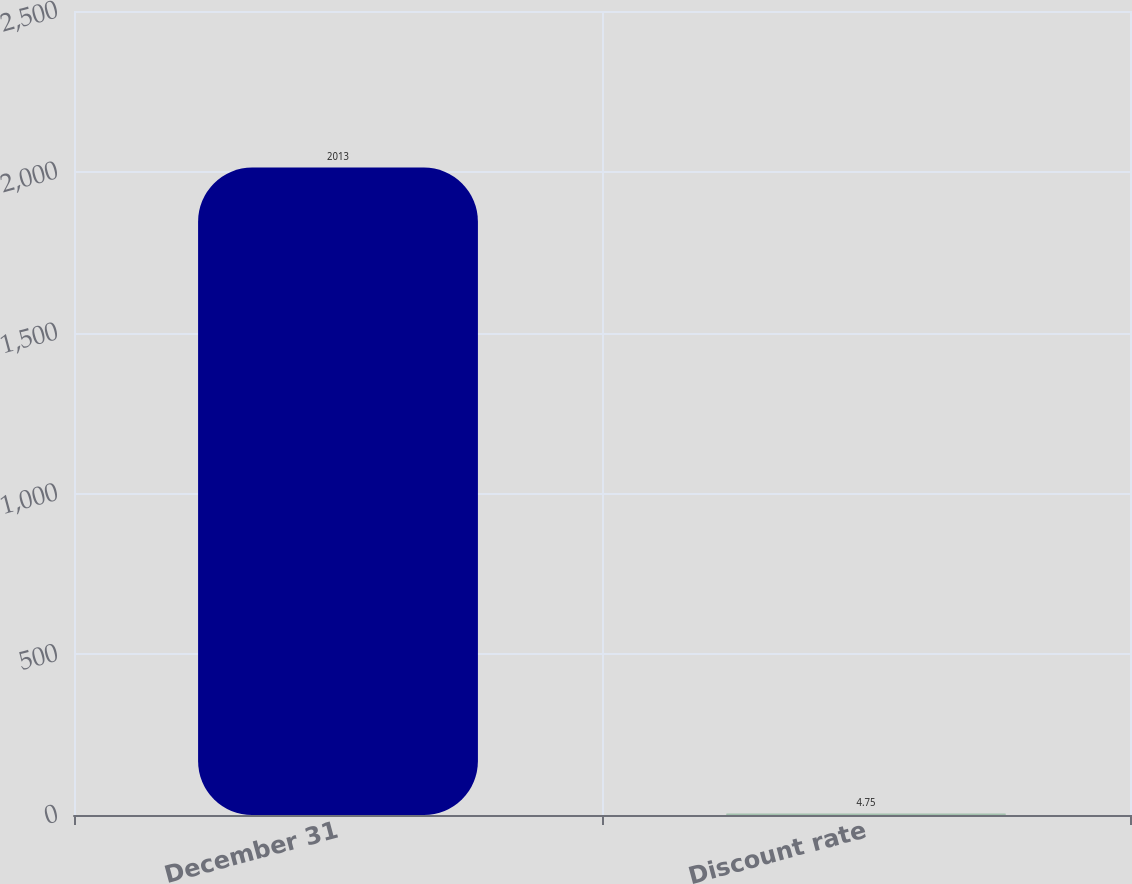Convert chart to OTSL. <chart><loc_0><loc_0><loc_500><loc_500><bar_chart><fcel>December 31<fcel>Discount rate<nl><fcel>2013<fcel>4.75<nl></chart> 